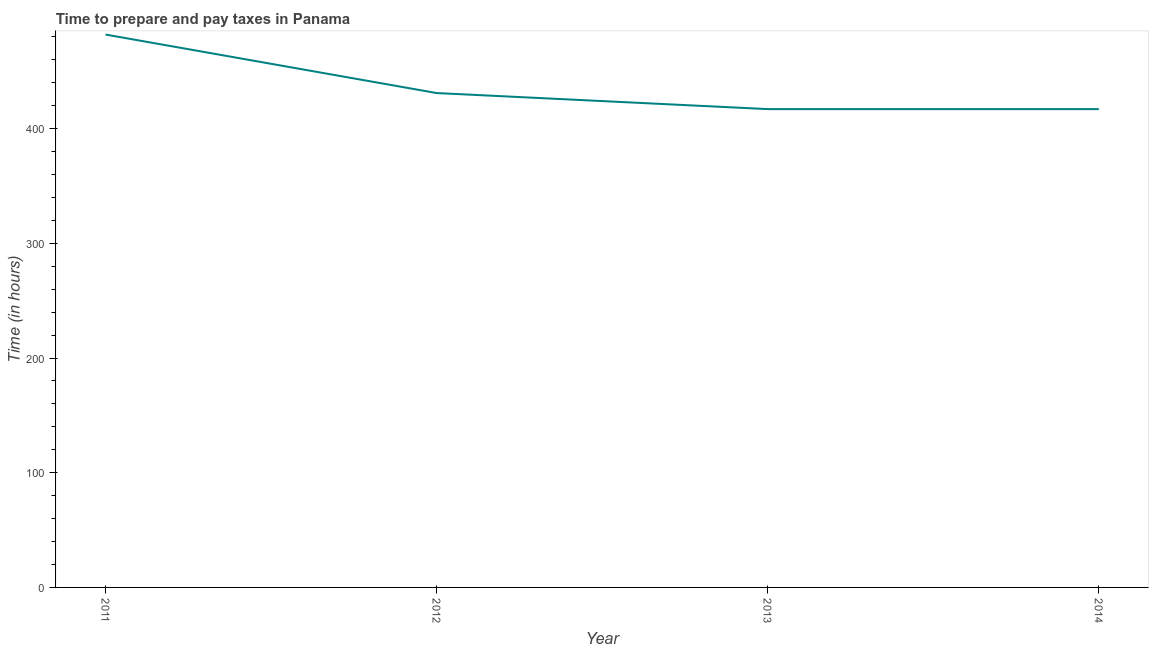What is the time to prepare and pay taxes in 2011?
Ensure brevity in your answer.  482. Across all years, what is the maximum time to prepare and pay taxes?
Give a very brief answer. 482. Across all years, what is the minimum time to prepare and pay taxes?
Provide a succinct answer. 417. In which year was the time to prepare and pay taxes minimum?
Make the answer very short. 2013. What is the sum of the time to prepare and pay taxes?
Offer a very short reply. 1747. What is the difference between the time to prepare and pay taxes in 2012 and 2014?
Give a very brief answer. 14. What is the average time to prepare and pay taxes per year?
Make the answer very short. 436.75. What is the median time to prepare and pay taxes?
Provide a short and direct response. 424. In how many years, is the time to prepare and pay taxes greater than 400 hours?
Provide a short and direct response. 4. What is the ratio of the time to prepare and pay taxes in 2011 to that in 2012?
Provide a succinct answer. 1.12. Is the time to prepare and pay taxes in 2013 less than that in 2014?
Your answer should be very brief. No. What is the difference between the highest and the lowest time to prepare and pay taxes?
Provide a succinct answer. 65. In how many years, is the time to prepare and pay taxes greater than the average time to prepare and pay taxes taken over all years?
Your answer should be very brief. 1. Does the time to prepare and pay taxes monotonically increase over the years?
Your answer should be compact. No. Are the values on the major ticks of Y-axis written in scientific E-notation?
Make the answer very short. No. Does the graph contain any zero values?
Your answer should be very brief. No. Does the graph contain grids?
Offer a terse response. No. What is the title of the graph?
Provide a short and direct response. Time to prepare and pay taxes in Panama. What is the label or title of the Y-axis?
Offer a terse response. Time (in hours). What is the Time (in hours) of 2011?
Your answer should be compact. 482. What is the Time (in hours) in 2012?
Your answer should be very brief. 431. What is the Time (in hours) in 2013?
Offer a very short reply. 417. What is the Time (in hours) of 2014?
Offer a terse response. 417. What is the difference between the Time (in hours) in 2011 and 2013?
Give a very brief answer. 65. What is the difference between the Time (in hours) in 2011 and 2014?
Offer a terse response. 65. What is the ratio of the Time (in hours) in 2011 to that in 2012?
Make the answer very short. 1.12. What is the ratio of the Time (in hours) in 2011 to that in 2013?
Provide a short and direct response. 1.16. What is the ratio of the Time (in hours) in 2011 to that in 2014?
Offer a terse response. 1.16. What is the ratio of the Time (in hours) in 2012 to that in 2013?
Make the answer very short. 1.03. What is the ratio of the Time (in hours) in 2012 to that in 2014?
Offer a terse response. 1.03. 